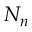Convert formula to latex. <formula><loc_0><loc_0><loc_500><loc_500>N _ { n }</formula> 